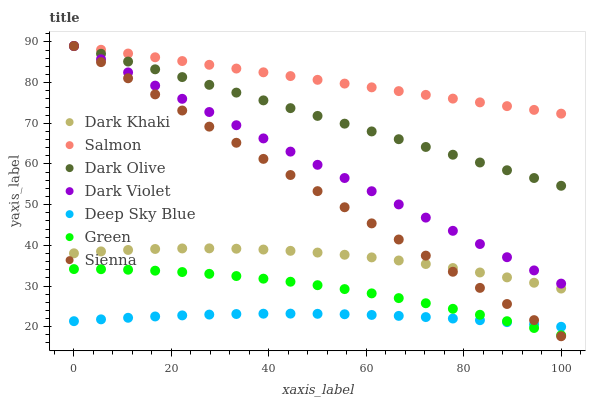Does Deep Sky Blue have the minimum area under the curve?
Answer yes or no. Yes. Does Salmon have the maximum area under the curve?
Answer yes or no. Yes. Does Dark Olive have the minimum area under the curve?
Answer yes or no. No. Does Dark Olive have the maximum area under the curve?
Answer yes or no. No. Is Salmon the smoothest?
Answer yes or no. Yes. Is Dark Khaki the roughest?
Answer yes or no. Yes. Is Dark Olive the smoothest?
Answer yes or no. No. Is Dark Olive the roughest?
Answer yes or no. No. Does Sienna have the lowest value?
Answer yes or no. Yes. Does Dark Olive have the lowest value?
Answer yes or no. No. Does Dark Violet have the highest value?
Answer yes or no. Yes. Does Dark Khaki have the highest value?
Answer yes or no. No. Is Dark Khaki less than Dark Olive?
Answer yes or no. Yes. Is Salmon greater than Green?
Answer yes or no. Yes. Does Dark Violet intersect Salmon?
Answer yes or no. Yes. Is Dark Violet less than Salmon?
Answer yes or no. No. Is Dark Violet greater than Salmon?
Answer yes or no. No. Does Dark Khaki intersect Dark Olive?
Answer yes or no. No. 